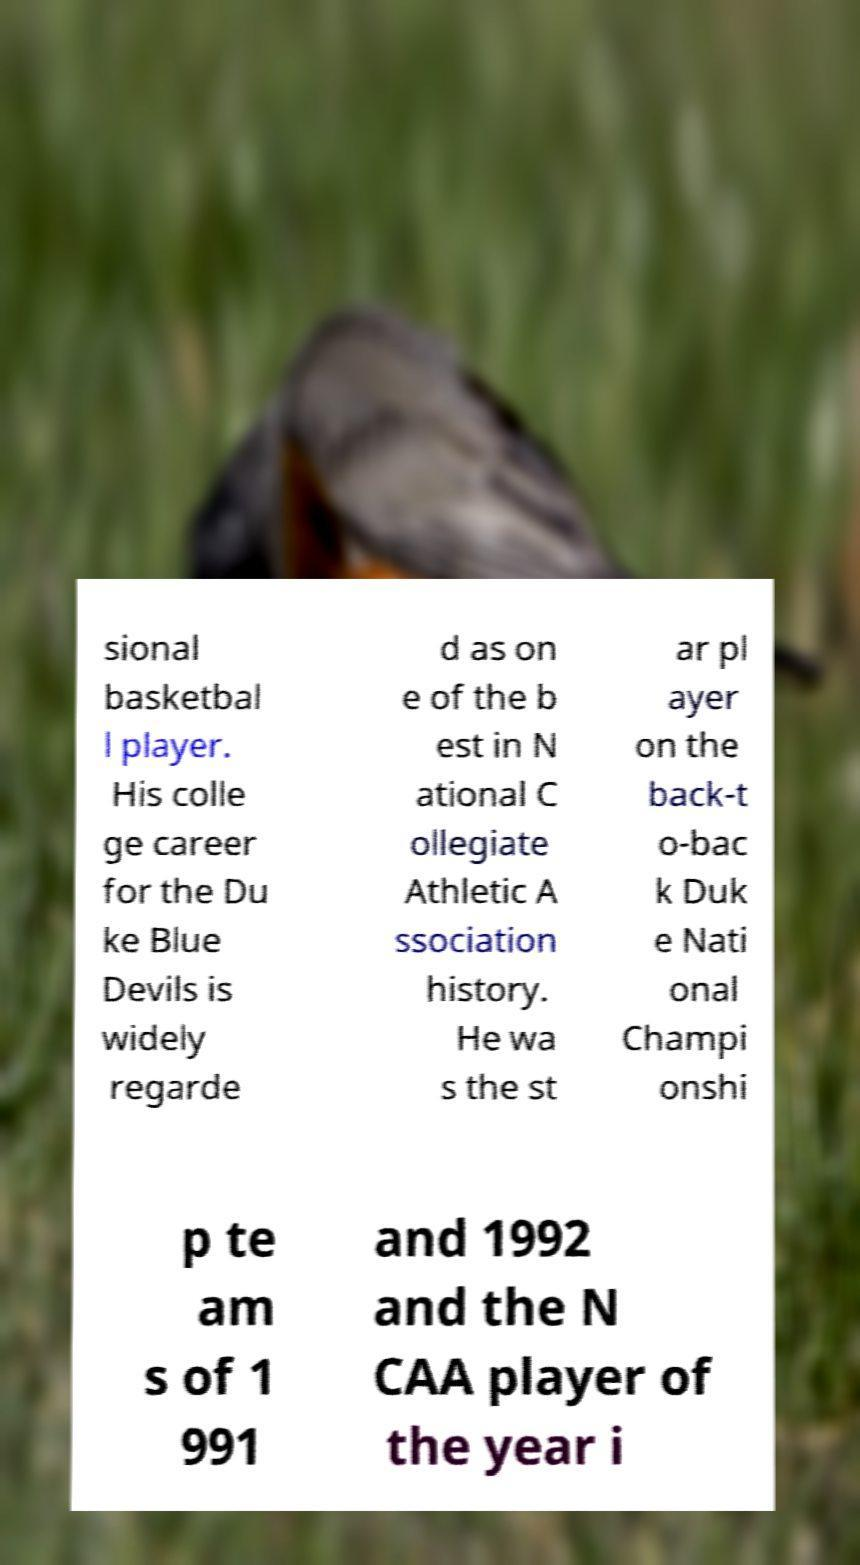Can you accurately transcribe the text from the provided image for me? sional basketbal l player. His colle ge career for the Du ke Blue Devils is widely regarde d as on e of the b est in N ational C ollegiate Athletic A ssociation history. He wa s the st ar pl ayer on the back-t o-bac k Duk e Nati onal Champi onshi p te am s of 1 991 and 1992 and the N CAA player of the year i 